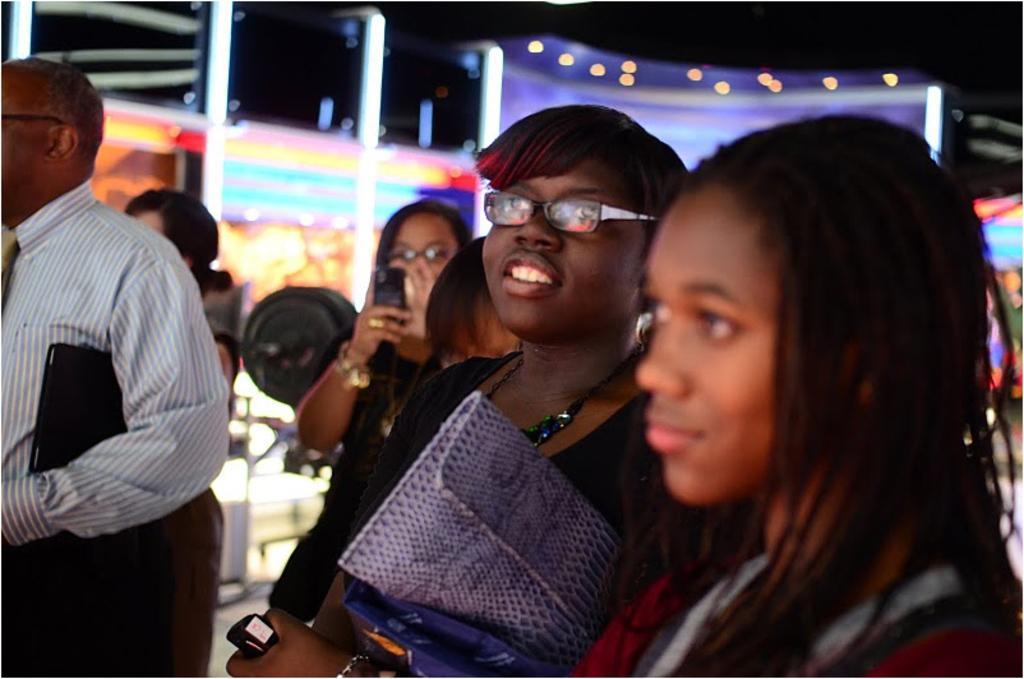In one or two sentences, can you explain what this image depicts? In this image there are five women and man, in the background there is a lighting. 